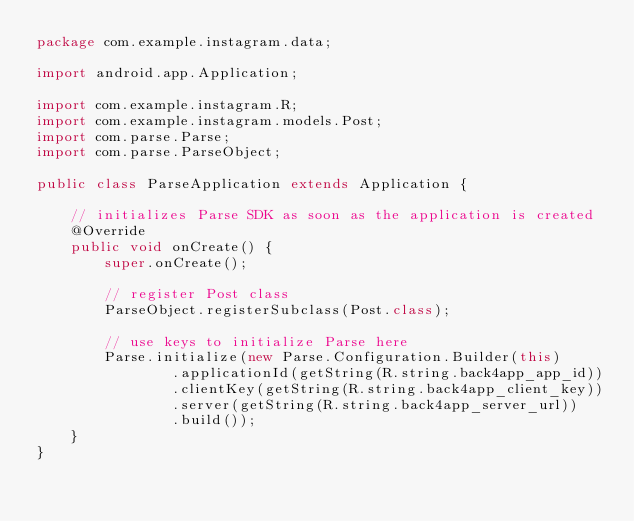Convert code to text. <code><loc_0><loc_0><loc_500><loc_500><_Java_>package com.example.instagram.data;

import android.app.Application;

import com.example.instagram.R;
import com.example.instagram.models.Post;
import com.parse.Parse;
import com.parse.ParseObject;

public class ParseApplication extends Application {

    // initializes Parse SDK as soon as the application is created
    @Override
    public void onCreate() {
        super.onCreate();

        // register Post class
        ParseObject.registerSubclass(Post.class);

        // use keys to initialize Parse here
        Parse.initialize(new Parse.Configuration.Builder(this)
                .applicationId(getString(R.string.back4app_app_id))
                .clientKey(getString(R.string.back4app_client_key))
                .server(getString(R.string.back4app_server_url))
                .build());
    }
}
</code> 